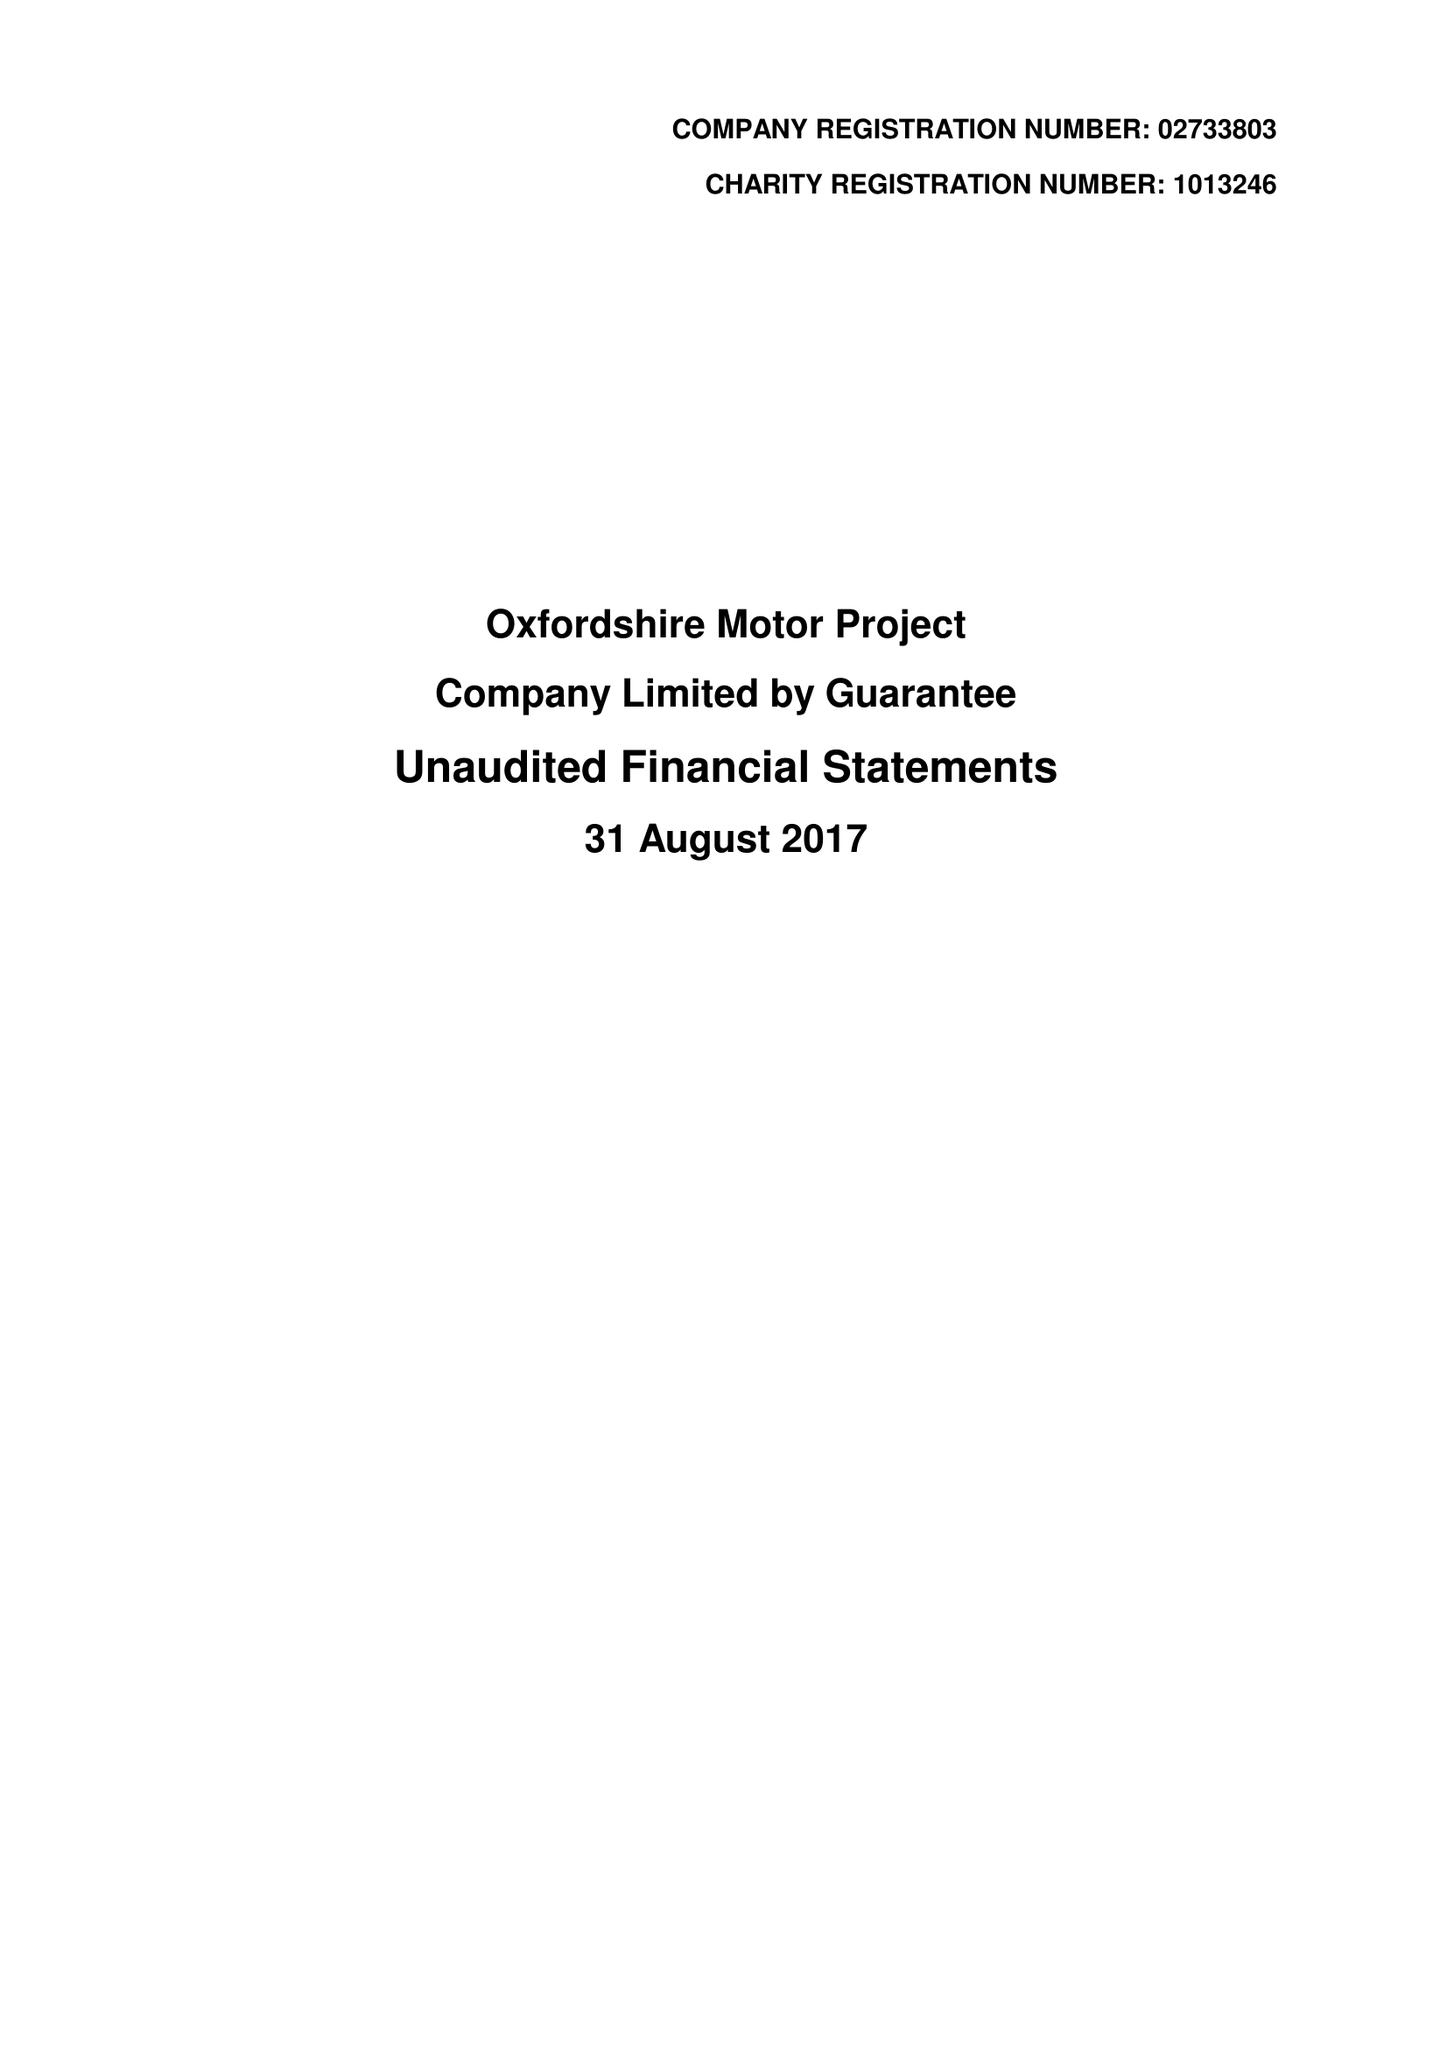What is the value for the spending_annually_in_british_pounds?
Answer the question using a single word or phrase. 351508.00 